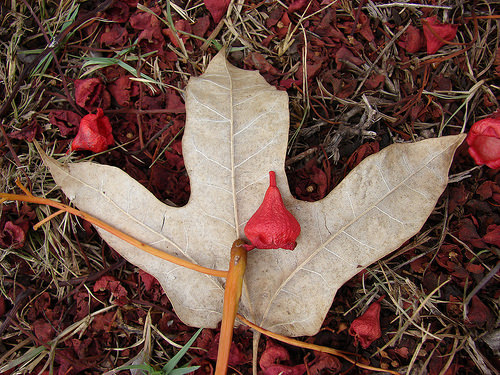<image>
Can you confirm if the twig is next to the leaf? No. The twig is not positioned next to the leaf. They are located in different areas of the scene. 